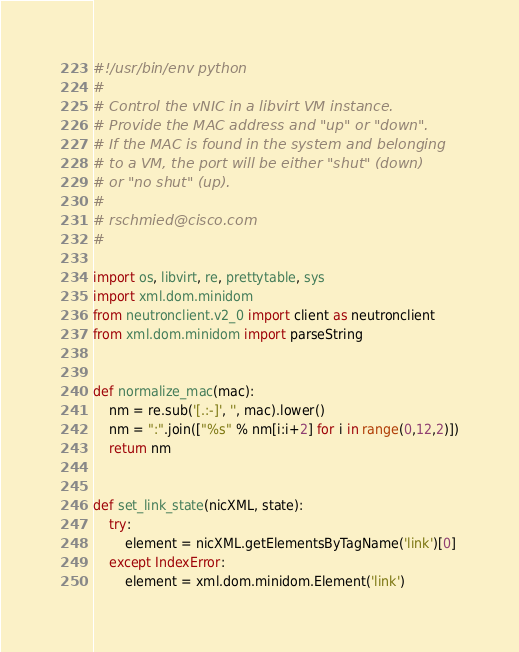<code> <loc_0><loc_0><loc_500><loc_500><_Python_>#!/usr/bin/env python
#
# Control the vNIC in a libvirt VM instance.
# Provide the MAC address and "up" or "down".
# If the MAC is found in the system and belonging
# to a VM, the port will be either "shut" (down) 
# or "no shut" (up).
#
# rschmied@cisco.com
#

import os, libvirt, re, prettytable, sys
import xml.dom.minidom
from neutronclient.v2_0 import client as neutronclient
from xml.dom.minidom import parseString


def normalize_mac(mac):
	nm = re.sub('[.:-]', '', mac).lower()
	nm = ":".join(["%s" % nm[i:i+2] for i in range(0,12,2)])
	return nm


def set_link_state(nicXML, state):
	try:
		element = nicXML.getElementsByTagName('link')[0]
	except IndexError:
		element = xml.dom.minidom.Element('link')</code> 